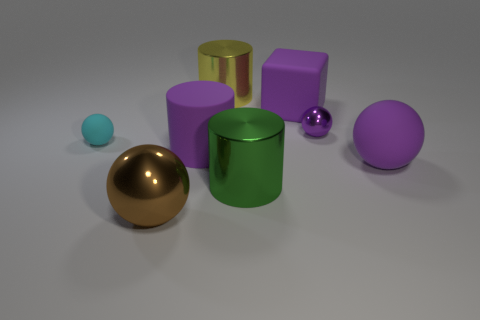Subtract 1 balls. How many balls are left? 3 Add 1 large purple objects. How many objects exist? 9 Subtract all cyan balls. Subtract all red cubes. How many balls are left? 3 Subtract all cylinders. How many objects are left? 5 Add 3 big metal spheres. How many big metal spheres are left? 4 Add 5 rubber balls. How many rubber balls exist? 7 Subtract 0 blue spheres. How many objects are left? 8 Subtract all big brown things. Subtract all tiny rubber things. How many objects are left? 6 